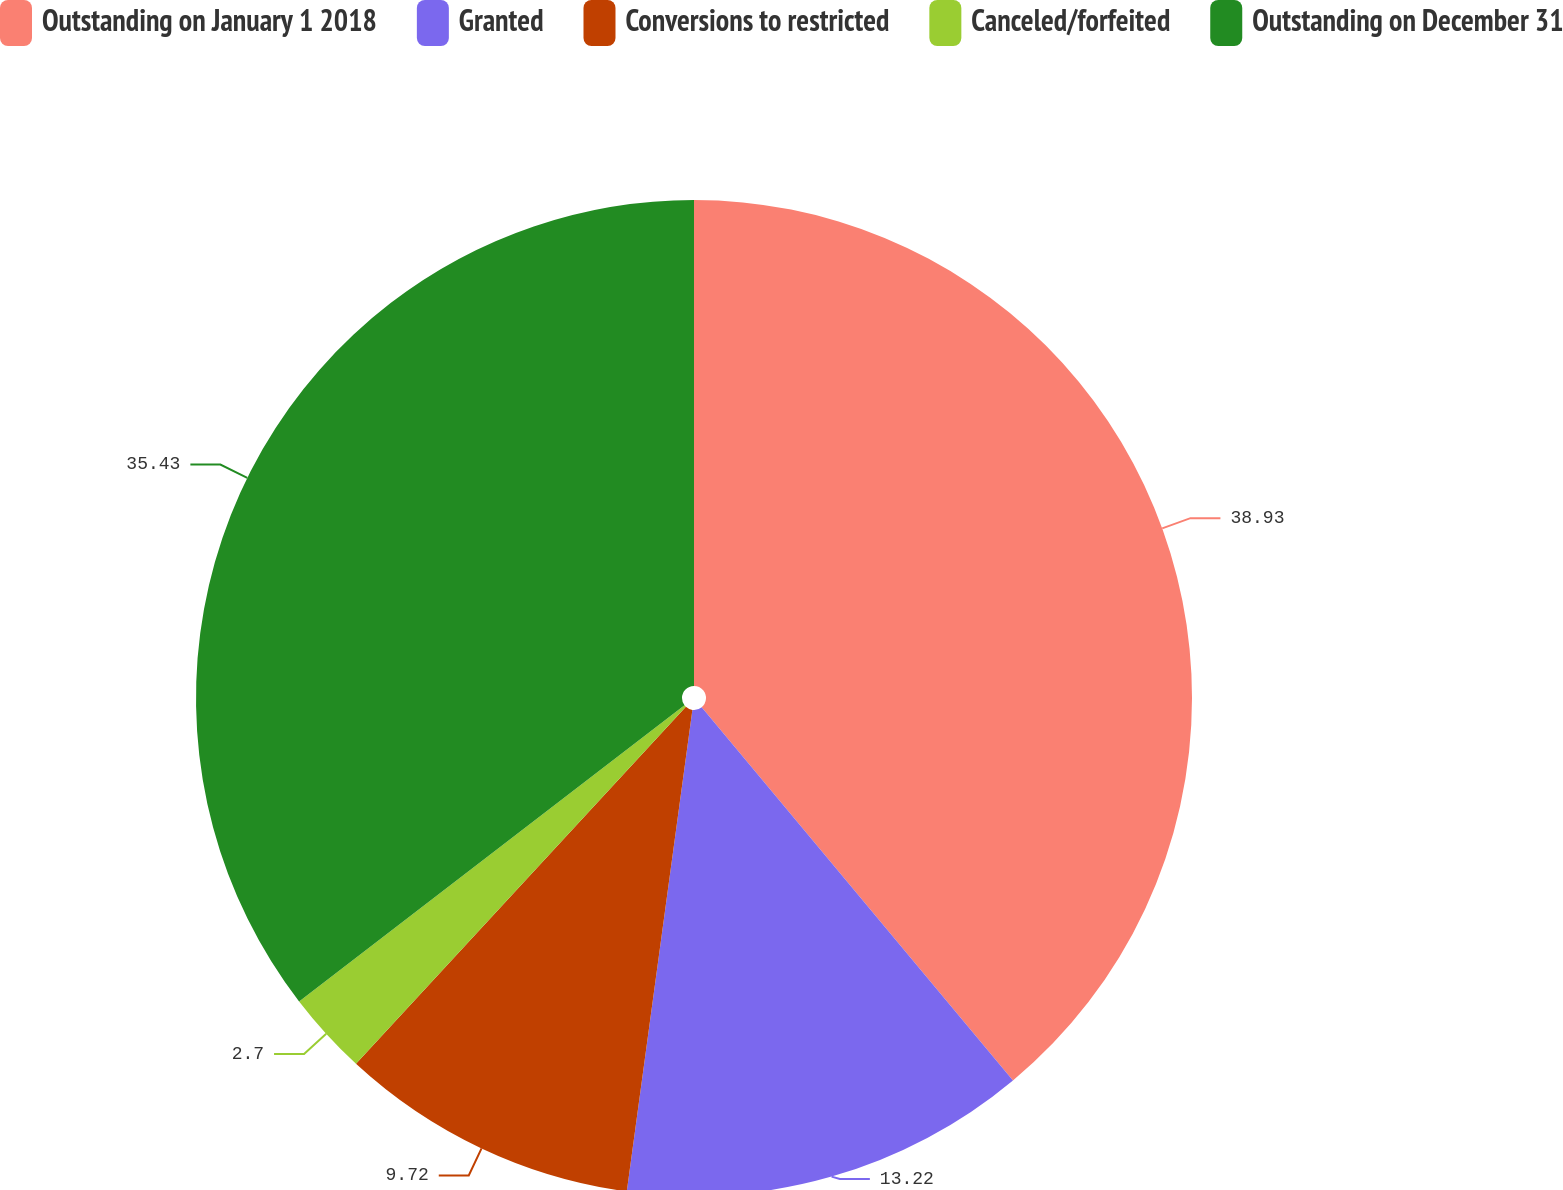Convert chart to OTSL. <chart><loc_0><loc_0><loc_500><loc_500><pie_chart><fcel>Outstanding on January 1 2018<fcel>Granted<fcel>Conversions to restricted<fcel>Canceled/forfeited<fcel>Outstanding on December 31<nl><fcel>38.94%<fcel>13.22%<fcel>9.72%<fcel>2.7%<fcel>35.43%<nl></chart> 